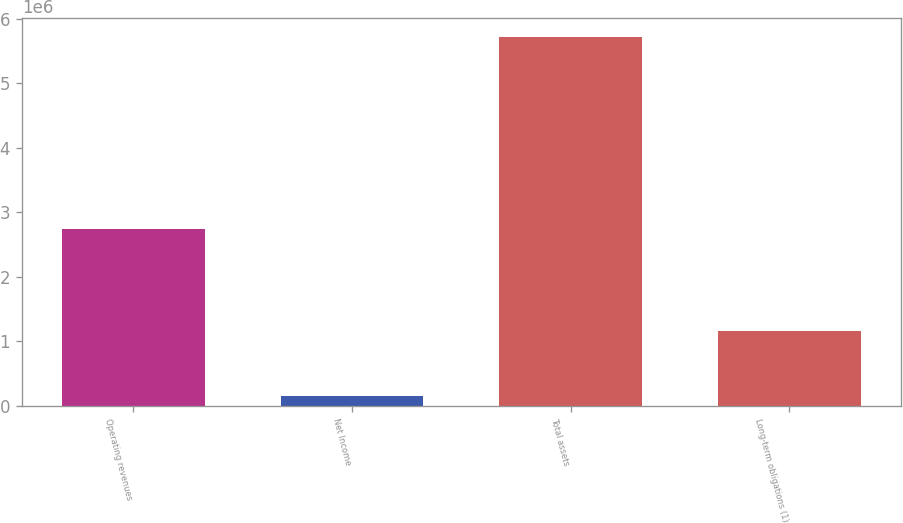Convert chart to OTSL. <chart><loc_0><loc_0><loc_500><loc_500><bar_chart><fcel>Operating revenues<fcel>Net Income<fcel>Total assets<fcel>Long-term obligations (1)<nl><fcel>2.73755e+06<fcel>143337<fcel>5.72312e+06<fcel>1.14948e+06<nl></chart> 